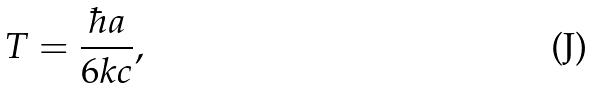Convert formula to latex. <formula><loc_0><loc_0><loc_500><loc_500>T = \frac { \hbar { a } } { 6 k c } ,</formula> 